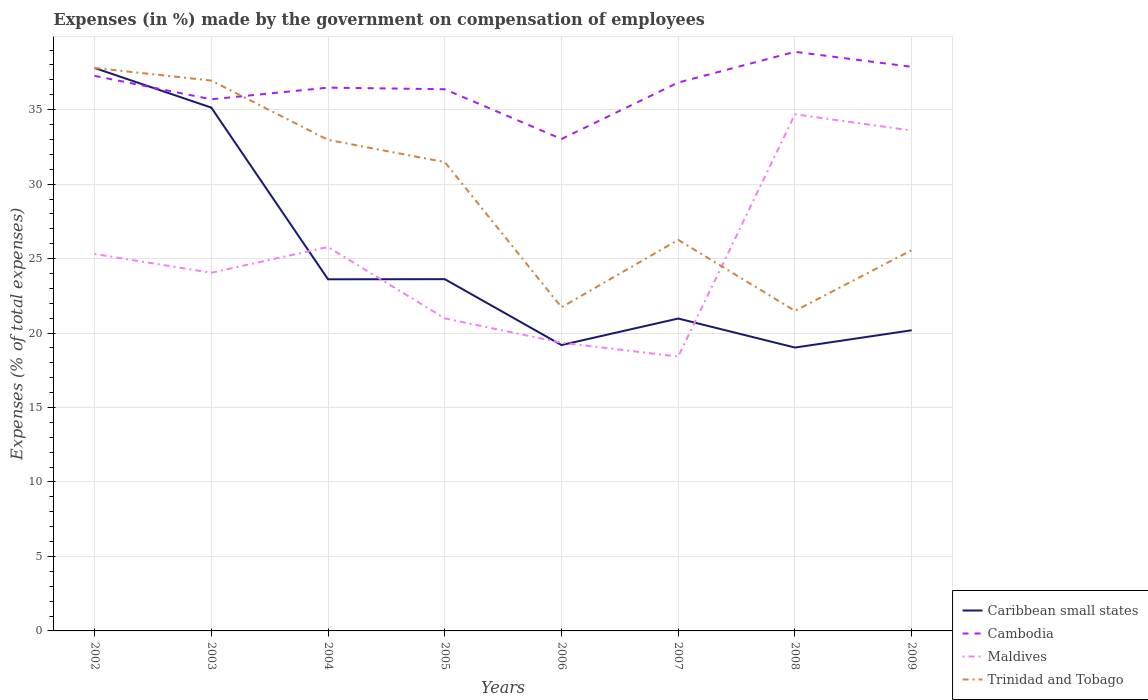Across all years, what is the maximum percentage of expenses made by the government on compensation of employees in Cambodia?
Give a very brief answer. 33.03. In which year was the percentage of expenses made by the government on compensation of employees in Cambodia maximum?
Provide a succinct answer. 2006. What is the total percentage of expenses made by the government on compensation of employees in Maldives in the graph?
Keep it short and to the point. -15.18. What is the difference between the highest and the second highest percentage of expenses made by the government on compensation of employees in Trinidad and Tobago?
Offer a very short reply. 16.31. What is the difference between two consecutive major ticks on the Y-axis?
Offer a terse response. 5. Are the values on the major ticks of Y-axis written in scientific E-notation?
Give a very brief answer. No. Does the graph contain any zero values?
Offer a very short reply. No. Where does the legend appear in the graph?
Provide a short and direct response. Bottom right. What is the title of the graph?
Provide a succinct answer. Expenses (in %) made by the government on compensation of employees. Does "Finland" appear as one of the legend labels in the graph?
Provide a succinct answer. No. What is the label or title of the Y-axis?
Your answer should be very brief. Expenses (% of total expenses). What is the Expenses (% of total expenses) of Caribbean small states in 2002?
Offer a terse response. 37.8. What is the Expenses (% of total expenses) of Cambodia in 2002?
Your answer should be very brief. 37.27. What is the Expenses (% of total expenses) of Maldives in 2002?
Offer a very short reply. 25.31. What is the Expenses (% of total expenses) in Trinidad and Tobago in 2002?
Offer a very short reply. 37.8. What is the Expenses (% of total expenses) of Caribbean small states in 2003?
Give a very brief answer. 35.14. What is the Expenses (% of total expenses) in Cambodia in 2003?
Your response must be concise. 35.7. What is the Expenses (% of total expenses) in Maldives in 2003?
Your answer should be compact. 24.05. What is the Expenses (% of total expenses) of Trinidad and Tobago in 2003?
Make the answer very short. 36.95. What is the Expenses (% of total expenses) of Caribbean small states in 2004?
Offer a very short reply. 23.61. What is the Expenses (% of total expenses) in Cambodia in 2004?
Offer a very short reply. 36.48. What is the Expenses (% of total expenses) in Maldives in 2004?
Give a very brief answer. 25.78. What is the Expenses (% of total expenses) in Trinidad and Tobago in 2004?
Provide a short and direct response. 32.97. What is the Expenses (% of total expenses) of Caribbean small states in 2005?
Offer a terse response. 23.62. What is the Expenses (% of total expenses) of Cambodia in 2005?
Make the answer very short. 36.37. What is the Expenses (% of total expenses) in Maldives in 2005?
Your answer should be very brief. 20.98. What is the Expenses (% of total expenses) in Trinidad and Tobago in 2005?
Your answer should be compact. 31.48. What is the Expenses (% of total expenses) of Caribbean small states in 2006?
Give a very brief answer. 19.19. What is the Expenses (% of total expenses) in Cambodia in 2006?
Make the answer very short. 33.03. What is the Expenses (% of total expenses) of Maldives in 2006?
Provide a succinct answer. 19.35. What is the Expenses (% of total expenses) of Trinidad and Tobago in 2006?
Keep it short and to the point. 21.73. What is the Expenses (% of total expenses) in Caribbean small states in 2007?
Offer a terse response. 20.98. What is the Expenses (% of total expenses) in Cambodia in 2007?
Provide a short and direct response. 36.82. What is the Expenses (% of total expenses) of Maldives in 2007?
Offer a very short reply. 18.42. What is the Expenses (% of total expenses) of Trinidad and Tobago in 2007?
Ensure brevity in your answer.  26.26. What is the Expenses (% of total expenses) of Caribbean small states in 2008?
Give a very brief answer. 19.03. What is the Expenses (% of total expenses) of Cambodia in 2008?
Your response must be concise. 38.88. What is the Expenses (% of total expenses) of Maldives in 2008?
Keep it short and to the point. 34.69. What is the Expenses (% of total expenses) in Trinidad and Tobago in 2008?
Provide a short and direct response. 21.49. What is the Expenses (% of total expenses) in Caribbean small states in 2009?
Make the answer very short. 20.19. What is the Expenses (% of total expenses) of Cambodia in 2009?
Ensure brevity in your answer.  37.88. What is the Expenses (% of total expenses) in Maldives in 2009?
Provide a succinct answer. 33.6. What is the Expenses (% of total expenses) in Trinidad and Tobago in 2009?
Give a very brief answer. 25.57. Across all years, what is the maximum Expenses (% of total expenses) of Caribbean small states?
Ensure brevity in your answer.  37.8. Across all years, what is the maximum Expenses (% of total expenses) in Cambodia?
Your response must be concise. 38.88. Across all years, what is the maximum Expenses (% of total expenses) in Maldives?
Your answer should be compact. 34.69. Across all years, what is the maximum Expenses (% of total expenses) in Trinidad and Tobago?
Make the answer very short. 37.8. Across all years, what is the minimum Expenses (% of total expenses) in Caribbean small states?
Make the answer very short. 19.03. Across all years, what is the minimum Expenses (% of total expenses) of Cambodia?
Provide a short and direct response. 33.03. Across all years, what is the minimum Expenses (% of total expenses) in Maldives?
Offer a very short reply. 18.42. Across all years, what is the minimum Expenses (% of total expenses) of Trinidad and Tobago?
Your response must be concise. 21.49. What is the total Expenses (% of total expenses) of Caribbean small states in the graph?
Provide a succinct answer. 199.54. What is the total Expenses (% of total expenses) in Cambodia in the graph?
Offer a very short reply. 292.42. What is the total Expenses (% of total expenses) of Maldives in the graph?
Your answer should be compact. 202.18. What is the total Expenses (% of total expenses) in Trinidad and Tobago in the graph?
Keep it short and to the point. 234.25. What is the difference between the Expenses (% of total expenses) of Caribbean small states in 2002 and that in 2003?
Provide a short and direct response. 2.66. What is the difference between the Expenses (% of total expenses) of Cambodia in 2002 and that in 2003?
Your response must be concise. 1.57. What is the difference between the Expenses (% of total expenses) in Maldives in 2002 and that in 2003?
Offer a very short reply. 1.26. What is the difference between the Expenses (% of total expenses) of Trinidad and Tobago in 2002 and that in 2003?
Offer a very short reply. 0.84. What is the difference between the Expenses (% of total expenses) of Caribbean small states in 2002 and that in 2004?
Your answer should be very brief. 14.19. What is the difference between the Expenses (% of total expenses) in Cambodia in 2002 and that in 2004?
Make the answer very short. 0.79. What is the difference between the Expenses (% of total expenses) of Maldives in 2002 and that in 2004?
Make the answer very short. -0.47. What is the difference between the Expenses (% of total expenses) in Trinidad and Tobago in 2002 and that in 2004?
Offer a terse response. 4.83. What is the difference between the Expenses (% of total expenses) of Caribbean small states in 2002 and that in 2005?
Offer a very short reply. 14.18. What is the difference between the Expenses (% of total expenses) in Cambodia in 2002 and that in 2005?
Provide a succinct answer. 0.9. What is the difference between the Expenses (% of total expenses) of Maldives in 2002 and that in 2005?
Offer a terse response. 4.33. What is the difference between the Expenses (% of total expenses) in Trinidad and Tobago in 2002 and that in 2005?
Give a very brief answer. 6.32. What is the difference between the Expenses (% of total expenses) of Caribbean small states in 2002 and that in 2006?
Your response must be concise. 18.6. What is the difference between the Expenses (% of total expenses) of Cambodia in 2002 and that in 2006?
Offer a very short reply. 4.24. What is the difference between the Expenses (% of total expenses) in Maldives in 2002 and that in 2006?
Give a very brief answer. 5.96. What is the difference between the Expenses (% of total expenses) in Trinidad and Tobago in 2002 and that in 2006?
Provide a succinct answer. 16.07. What is the difference between the Expenses (% of total expenses) in Caribbean small states in 2002 and that in 2007?
Your answer should be compact. 16.82. What is the difference between the Expenses (% of total expenses) in Cambodia in 2002 and that in 2007?
Ensure brevity in your answer.  0.45. What is the difference between the Expenses (% of total expenses) of Maldives in 2002 and that in 2007?
Your response must be concise. 6.89. What is the difference between the Expenses (% of total expenses) in Trinidad and Tobago in 2002 and that in 2007?
Your response must be concise. 11.54. What is the difference between the Expenses (% of total expenses) of Caribbean small states in 2002 and that in 2008?
Your answer should be compact. 18.77. What is the difference between the Expenses (% of total expenses) in Cambodia in 2002 and that in 2008?
Ensure brevity in your answer.  -1.61. What is the difference between the Expenses (% of total expenses) in Maldives in 2002 and that in 2008?
Ensure brevity in your answer.  -9.38. What is the difference between the Expenses (% of total expenses) in Trinidad and Tobago in 2002 and that in 2008?
Offer a terse response. 16.31. What is the difference between the Expenses (% of total expenses) of Caribbean small states in 2002 and that in 2009?
Provide a short and direct response. 17.61. What is the difference between the Expenses (% of total expenses) of Cambodia in 2002 and that in 2009?
Ensure brevity in your answer.  -0.61. What is the difference between the Expenses (% of total expenses) in Maldives in 2002 and that in 2009?
Provide a succinct answer. -8.29. What is the difference between the Expenses (% of total expenses) of Trinidad and Tobago in 2002 and that in 2009?
Keep it short and to the point. 12.23. What is the difference between the Expenses (% of total expenses) in Caribbean small states in 2003 and that in 2004?
Provide a short and direct response. 11.53. What is the difference between the Expenses (% of total expenses) of Cambodia in 2003 and that in 2004?
Provide a succinct answer. -0.78. What is the difference between the Expenses (% of total expenses) of Maldives in 2003 and that in 2004?
Make the answer very short. -1.73. What is the difference between the Expenses (% of total expenses) in Trinidad and Tobago in 2003 and that in 2004?
Provide a short and direct response. 3.98. What is the difference between the Expenses (% of total expenses) of Caribbean small states in 2003 and that in 2005?
Offer a very short reply. 11.52. What is the difference between the Expenses (% of total expenses) in Cambodia in 2003 and that in 2005?
Offer a very short reply. -0.68. What is the difference between the Expenses (% of total expenses) of Maldives in 2003 and that in 2005?
Ensure brevity in your answer.  3.07. What is the difference between the Expenses (% of total expenses) in Trinidad and Tobago in 2003 and that in 2005?
Make the answer very short. 5.48. What is the difference between the Expenses (% of total expenses) in Caribbean small states in 2003 and that in 2006?
Give a very brief answer. 15.94. What is the difference between the Expenses (% of total expenses) in Cambodia in 2003 and that in 2006?
Provide a short and direct response. 2.67. What is the difference between the Expenses (% of total expenses) of Maldives in 2003 and that in 2006?
Offer a very short reply. 4.7. What is the difference between the Expenses (% of total expenses) of Trinidad and Tobago in 2003 and that in 2006?
Provide a succinct answer. 15.22. What is the difference between the Expenses (% of total expenses) in Caribbean small states in 2003 and that in 2007?
Keep it short and to the point. 14.16. What is the difference between the Expenses (% of total expenses) in Cambodia in 2003 and that in 2007?
Your answer should be very brief. -1.13. What is the difference between the Expenses (% of total expenses) of Maldives in 2003 and that in 2007?
Your response must be concise. 5.63. What is the difference between the Expenses (% of total expenses) of Trinidad and Tobago in 2003 and that in 2007?
Ensure brevity in your answer.  10.7. What is the difference between the Expenses (% of total expenses) of Caribbean small states in 2003 and that in 2008?
Provide a succinct answer. 16.11. What is the difference between the Expenses (% of total expenses) in Cambodia in 2003 and that in 2008?
Provide a short and direct response. -3.19. What is the difference between the Expenses (% of total expenses) in Maldives in 2003 and that in 2008?
Offer a terse response. -10.64. What is the difference between the Expenses (% of total expenses) of Trinidad and Tobago in 2003 and that in 2008?
Offer a very short reply. 15.46. What is the difference between the Expenses (% of total expenses) in Caribbean small states in 2003 and that in 2009?
Your answer should be compact. 14.95. What is the difference between the Expenses (% of total expenses) in Cambodia in 2003 and that in 2009?
Make the answer very short. -2.18. What is the difference between the Expenses (% of total expenses) in Maldives in 2003 and that in 2009?
Keep it short and to the point. -9.55. What is the difference between the Expenses (% of total expenses) in Trinidad and Tobago in 2003 and that in 2009?
Your response must be concise. 11.39. What is the difference between the Expenses (% of total expenses) in Caribbean small states in 2004 and that in 2005?
Provide a succinct answer. -0.01. What is the difference between the Expenses (% of total expenses) in Cambodia in 2004 and that in 2005?
Your answer should be very brief. 0.11. What is the difference between the Expenses (% of total expenses) of Maldives in 2004 and that in 2005?
Offer a very short reply. 4.79. What is the difference between the Expenses (% of total expenses) in Trinidad and Tobago in 2004 and that in 2005?
Your response must be concise. 1.49. What is the difference between the Expenses (% of total expenses) of Caribbean small states in 2004 and that in 2006?
Keep it short and to the point. 4.41. What is the difference between the Expenses (% of total expenses) in Cambodia in 2004 and that in 2006?
Give a very brief answer. 3.45. What is the difference between the Expenses (% of total expenses) in Maldives in 2004 and that in 2006?
Ensure brevity in your answer.  6.43. What is the difference between the Expenses (% of total expenses) in Trinidad and Tobago in 2004 and that in 2006?
Provide a short and direct response. 11.24. What is the difference between the Expenses (% of total expenses) of Caribbean small states in 2004 and that in 2007?
Provide a succinct answer. 2.63. What is the difference between the Expenses (% of total expenses) of Cambodia in 2004 and that in 2007?
Keep it short and to the point. -0.34. What is the difference between the Expenses (% of total expenses) in Maldives in 2004 and that in 2007?
Give a very brief answer. 7.36. What is the difference between the Expenses (% of total expenses) in Trinidad and Tobago in 2004 and that in 2007?
Provide a succinct answer. 6.71. What is the difference between the Expenses (% of total expenses) in Caribbean small states in 2004 and that in 2008?
Offer a terse response. 4.58. What is the difference between the Expenses (% of total expenses) of Cambodia in 2004 and that in 2008?
Ensure brevity in your answer.  -2.41. What is the difference between the Expenses (% of total expenses) of Maldives in 2004 and that in 2008?
Offer a terse response. -8.91. What is the difference between the Expenses (% of total expenses) of Trinidad and Tobago in 2004 and that in 2008?
Make the answer very short. 11.48. What is the difference between the Expenses (% of total expenses) in Caribbean small states in 2004 and that in 2009?
Make the answer very short. 3.42. What is the difference between the Expenses (% of total expenses) in Cambodia in 2004 and that in 2009?
Your answer should be very brief. -1.4. What is the difference between the Expenses (% of total expenses) in Maldives in 2004 and that in 2009?
Offer a very short reply. -7.82. What is the difference between the Expenses (% of total expenses) in Trinidad and Tobago in 2004 and that in 2009?
Offer a very short reply. 7.4. What is the difference between the Expenses (% of total expenses) in Caribbean small states in 2005 and that in 2006?
Your response must be concise. 4.42. What is the difference between the Expenses (% of total expenses) of Cambodia in 2005 and that in 2006?
Your response must be concise. 3.34. What is the difference between the Expenses (% of total expenses) in Maldives in 2005 and that in 2006?
Your response must be concise. 1.63. What is the difference between the Expenses (% of total expenses) in Trinidad and Tobago in 2005 and that in 2006?
Offer a very short reply. 9.75. What is the difference between the Expenses (% of total expenses) of Caribbean small states in 2005 and that in 2007?
Your response must be concise. 2.64. What is the difference between the Expenses (% of total expenses) of Cambodia in 2005 and that in 2007?
Your answer should be very brief. -0.45. What is the difference between the Expenses (% of total expenses) of Maldives in 2005 and that in 2007?
Provide a short and direct response. 2.56. What is the difference between the Expenses (% of total expenses) of Trinidad and Tobago in 2005 and that in 2007?
Provide a short and direct response. 5.22. What is the difference between the Expenses (% of total expenses) in Caribbean small states in 2005 and that in 2008?
Offer a very short reply. 4.59. What is the difference between the Expenses (% of total expenses) of Cambodia in 2005 and that in 2008?
Your response must be concise. -2.51. What is the difference between the Expenses (% of total expenses) of Maldives in 2005 and that in 2008?
Your answer should be compact. -13.71. What is the difference between the Expenses (% of total expenses) of Trinidad and Tobago in 2005 and that in 2008?
Give a very brief answer. 9.99. What is the difference between the Expenses (% of total expenses) of Caribbean small states in 2005 and that in 2009?
Your answer should be compact. 3.43. What is the difference between the Expenses (% of total expenses) of Cambodia in 2005 and that in 2009?
Your answer should be compact. -1.5. What is the difference between the Expenses (% of total expenses) of Maldives in 2005 and that in 2009?
Keep it short and to the point. -12.61. What is the difference between the Expenses (% of total expenses) in Trinidad and Tobago in 2005 and that in 2009?
Offer a very short reply. 5.91. What is the difference between the Expenses (% of total expenses) in Caribbean small states in 2006 and that in 2007?
Offer a very short reply. -1.78. What is the difference between the Expenses (% of total expenses) of Cambodia in 2006 and that in 2007?
Your answer should be very brief. -3.79. What is the difference between the Expenses (% of total expenses) of Maldives in 2006 and that in 2007?
Provide a succinct answer. 0.93. What is the difference between the Expenses (% of total expenses) in Trinidad and Tobago in 2006 and that in 2007?
Give a very brief answer. -4.53. What is the difference between the Expenses (% of total expenses) of Caribbean small states in 2006 and that in 2008?
Your answer should be very brief. 0.17. What is the difference between the Expenses (% of total expenses) in Cambodia in 2006 and that in 2008?
Give a very brief answer. -5.85. What is the difference between the Expenses (% of total expenses) of Maldives in 2006 and that in 2008?
Your response must be concise. -15.34. What is the difference between the Expenses (% of total expenses) in Trinidad and Tobago in 2006 and that in 2008?
Give a very brief answer. 0.24. What is the difference between the Expenses (% of total expenses) of Caribbean small states in 2006 and that in 2009?
Provide a short and direct response. -0.99. What is the difference between the Expenses (% of total expenses) of Cambodia in 2006 and that in 2009?
Offer a terse response. -4.85. What is the difference between the Expenses (% of total expenses) in Maldives in 2006 and that in 2009?
Give a very brief answer. -14.25. What is the difference between the Expenses (% of total expenses) of Trinidad and Tobago in 2006 and that in 2009?
Your response must be concise. -3.84. What is the difference between the Expenses (% of total expenses) in Caribbean small states in 2007 and that in 2008?
Offer a very short reply. 1.95. What is the difference between the Expenses (% of total expenses) of Cambodia in 2007 and that in 2008?
Offer a very short reply. -2.06. What is the difference between the Expenses (% of total expenses) in Maldives in 2007 and that in 2008?
Offer a very short reply. -16.27. What is the difference between the Expenses (% of total expenses) in Trinidad and Tobago in 2007 and that in 2008?
Keep it short and to the point. 4.77. What is the difference between the Expenses (% of total expenses) of Caribbean small states in 2007 and that in 2009?
Ensure brevity in your answer.  0.79. What is the difference between the Expenses (% of total expenses) in Cambodia in 2007 and that in 2009?
Offer a very short reply. -1.05. What is the difference between the Expenses (% of total expenses) in Maldives in 2007 and that in 2009?
Give a very brief answer. -15.18. What is the difference between the Expenses (% of total expenses) in Trinidad and Tobago in 2007 and that in 2009?
Make the answer very short. 0.69. What is the difference between the Expenses (% of total expenses) in Caribbean small states in 2008 and that in 2009?
Ensure brevity in your answer.  -1.16. What is the difference between the Expenses (% of total expenses) in Cambodia in 2008 and that in 2009?
Give a very brief answer. 1.01. What is the difference between the Expenses (% of total expenses) in Maldives in 2008 and that in 2009?
Give a very brief answer. 1.09. What is the difference between the Expenses (% of total expenses) in Trinidad and Tobago in 2008 and that in 2009?
Give a very brief answer. -4.08. What is the difference between the Expenses (% of total expenses) in Caribbean small states in 2002 and the Expenses (% of total expenses) in Cambodia in 2003?
Provide a succinct answer. 2.1. What is the difference between the Expenses (% of total expenses) of Caribbean small states in 2002 and the Expenses (% of total expenses) of Maldives in 2003?
Make the answer very short. 13.75. What is the difference between the Expenses (% of total expenses) of Caribbean small states in 2002 and the Expenses (% of total expenses) of Trinidad and Tobago in 2003?
Keep it short and to the point. 0.84. What is the difference between the Expenses (% of total expenses) in Cambodia in 2002 and the Expenses (% of total expenses) in Maldives in 2003?
Give a very brief answer. 13.22. What is the difference between the Expenses (% of total expenses) in Cambodia in 2002 and the Expenses (% of total expenses) in Trinidad and Tobago in 2003?
Your answer should be very brief. 0.32. What is the difference between the Expenses (% of total expenses) in Maldives in 2002 and the Expenses (% of total expenses) in Trinidad and Tobago in 2003?
Offer a terse response. -11.64. What is the difference between the Expenses (% of total expenses) of Caribbean small states in 2002 and the Expenses (% of total expenses) of Cambodia in 2004?
Make the answer very short. 1.32. What is the difference between the Expenses (% of total expenses) of Caribbean small states in 2002 and the Expenses (% of total expenses) of Maldives in 2004?
Provide a succinct answer. 12.02. What is the difference between the Expenses (% of total expenses) of Caribbean small states in 2002 and the Expenses (% of total expenses) of Trinidad and Tobago in 2004?
Provide a succinct answer. 4.83. What is the difference between the Expenses (% of total expenses) of Cambodia in 2002 and the Expenses (% of total expenses) of Maldives in 2004?
Provide a succinct answer. 11.49. What is the difference between the Expenses (% of total expenses) of Cambodia in 2002 and the Expenses (% of total expenses) of Trinidad and Tobago in 2004?
Provide a succinct answer. 4.3. What is the difference between the Expenses (% of total expenses) in Maldives in 2002 and the Expenses (% of total expenses) in Trinidad and Tobago in 2004?
Provide a succinct answer. -7.66. What is the difference between the Expenses (% of total expenses) in Caribbean small states in 2002 and the Expenses (% of total expenses) in Cambodia in 2005?
Your response must be concise. 1.43. What is the difference between the Expenses (% of total expenses) in Caribbean small states in 2002 and the Expenses (% of total expenses) in Maldives in 2005?
Provide a short and direct response. 16.81. What is the difference between the Expenses (% of total expenses) in Caribbean small states in 2002 and the Expenses (% of total expenses) in Trinidad and Tobago in 2005?
Your answer should be compact. 6.32. What is the difference between the Expenses (% of total expenses) of Cambodia in 2002 and the Expenses (% of total expenses) of Maldives in 2005?
Make the answer very short. 16.29. What is the difference between the Expenses (% of total expenses) of Cambodia in 2002 and the Expenses (% of total expenses) of Trinidad and Tobago in 2005?
Your response must be concise. 5.79. What is the difference between the Expenses (% of total expenses) of Maldives in 2002 and the Expenses (% of total expenses) of Trinidad and Tobago in 2005?
Your response must be concise. -6.17. What is the difference between the Expenses (% of total expenses) in Caribbean small states in 2002 and the Expenses (% of total expenses) in Cambodia in 2006?
Provide a short and direct response. 4.77. What is the difference between the Expenses (% of total expenses) in Caribbean small states in 2002 and the Expenses (% of total expenses) in Maldives in 2006?
Your answer should be very brief. 18.45. What is the difference between the Expenses (% of total expenses) of Caribbean small states in 2002 and the Expenses (% of total expenses) of Trinidad and Tobago in 2006?
Keep it short and to the point. 16.07. What is the difference between the Expenses (% of total expenses) of Cambodia in 2002 and the Expenses (% of total expenses) of Maldives in 2006?
Your answer should be very brief. 17.92. What is the difference between the Expenses (% of total expenses) in Cambodia in 2002 and the Expenses (% of total expenses) in Trinidad and Tobago in 2006?
Provide a succinct answer. 15.54. What is the difference between the Expenses (% of total expenses) in Maldives in 2002 and the Expenses (% of total expenses) in Trinidad and Tobago in 2006?
Offer a terse response. 3.58. What is the difference between the Expenses (% of total expenses) of Caribbean small states in 2002 and the Expenses (% of total expenses) of Cambodia in 2007?
Your answer should be very brief. 0.98. What is the difference between the Expenses (% of total expenses) in Caribbean small states in 2002 and the Expenses (% of total expenses) in Maldives in 2007?
Keep it short and to the point. 19.38. What is the difference between the Expenses (% of total expenses) of Caribbean small states in 2002 and the Expenses (% of total expenses) of Trinidad and Tobago in 2007?
Give a very brief answer. 11.54. What is the difference between the Expenses (% of total expenses) in Cambodia in 2002 and the Expenses (% of total expenses) in Maldives in 2007?
Offer a very short reply. 18.85. What is the difference between the Expenses (% of total expenses) in Cambodia in 2002 and the Expenses (% of total expenses) in Trinidad and Tobago in 2007?
Provide a short and direct response. 11.01. What is the difference between the Expenses (% of total expenses) in Maldives in 2002 and the Expenses (% of total expenses) in Trinidad and Tobago in 2007?
Your answer should be very brief. -0.95. What is the difference between the Expenses (% of total expenses) of Caribbean small states in 2002 and the Expenses (% of total expenses) of Cambodia in 2008?
Keep it short and to the point. -1.09. What is the difference between the Expenses (% of total expenses) in Caribbean small states in 2002 and the Expenses (% of total expenses) in Maldives in 2008?
Your response must be concise. 3.11. What is the difference between the Expenses (% of total expenses) of Caribbean small states in 2002 and the Expenses (% of total expenses) of Trinidad and Tobago in 2008?
Your answer should be compact. 16.31. What is the difference between the Expenses (% of total expenses) of Cambodia in 2002 and the Expenses (% of total expenses) of Maldives in 2008?
Your response must be concise. 2.58. What is the difference between the Expenses (% of total expenses) in Cambodia in 2002 and the Expenses (% of total expenses) in Trinidad and Tobago in 2008?
Your response must be concise. 15.78. What is the difference between the Expenses (% of total expenses) in Maldives in 2002 and the Expenses (% of total expenses) in Trinidad and Tobago in 2008?
Your response must be concise. 3.82. What is the difference between the Expenses (% of total expenses) in Caribbean small states in 2002 and the Expenses (% of total expenses) in Cambodia in 2009?
Your response must be concise. -0.08. What is the difference between the Expenses (% of total expenses) in Caribbean small states in 2002 and the Expenses (% of total expenses) in Maldives in 2009?
Make the answer very short. 4.2. What is the difference between the Expenses (% of total expenses) of Caribbean small states in 2002 and the Expenses (% of total expenses) of Trinidad and Tobago in 2009?
Keep it short and to the point. 12.23. What is the difference between the Expenses (% of total expenses) in Cambodia in 2002 and the Expenses (% of total expenses) in Maldives in 2009?
Your response must be concise. 3.67. What is the difference between the Expenses (% of total expenses) in Cambodia in 2002 and the Expenses (% of total expenses) in Trinidad and Tobago in 2009?
Ensure brevity in your answer.  11.7. What is the difference between the Expenses (% of total expenses) in Maldives in 2002 and the Expenses (% of total expenses) in Trinidad and Tobago in 2009?
Make the answer very short. -0.26. What is the difference between the Expenses (% of total expenses) in Caribbean small states in 2003 and the Expenses (% of total expenses) in Cambodia in 2004?
Your response must be concise. -1.34. What is the difference between the Expenses (% of total expenses) in Caribbean small states in 2003 and the Expenses (% of total expenses) in Maldives in 2004?
Offer a terse response. 9.36. What is the difference between the Expenses (% of total expenses) in Caribbean small states in 2003 and the Expenses (% of total expenses) in Trinidad and Tobago in 2004?
Make the answer very short. 2.17. What is the difference between the Expenses (% of total expenses) in Cambodia in 2003 and the Expenses (% of total expenses) in Maldives in 2004?
Keep it short and to the point. 9.92. What is the difference between the Expenses (% of total expenses) of Cambodia in 2003 and the Expenses (% of total expenses) of Trinidad and Tobago in 2004?
Your answer should be very brief. 2.72. What is the difference between the Expenses (% of total expenses) in Maldives in 2003 and the Expenses (% of total expenses) in Trinidad and Tobago in 2004?
Your answer should be very brief. -8.92. What is the difference between the Expenses (% of total expenses) in Caribbean small states in 2003 and the Expenses (% of total expenses) in Cambodia in 2005?
Offer a very short reply. -1.23. What is the difference between the Expenses (% of total expenses) of Caribbean small states in 2003 and the Expenses (% of total expenses) of Maldives in 2005?
Offer a very short reply. 14.15. What is the difference between the Expenses (% of total expenses) of Caribbean small states in 2003 and the Expenses (% of total expenses) of Trinidad and Tobago in 2005?
Your answer should be compact. 3.66. What is the difference between the Expenses (% of total expenses) in Cambodia in 2003 and the Expenses (% of total expenses) in Maldives in 2005?
Provide a short and direct response. 14.71. What is the difference between the Expenses (% of total expenses) of Cambodia in 2003 and the Expenses (% of total expenses) of Trinidad and Tobago in 2005?
Make the answer very short. 4.22. What is the difference between the Expenses (% of total expenses) of Maldives in 2003 and the Expenses (% of total expenses) of Trinidad and Tobago in 2005?
Ensure brevity in your answer.  -7.43. What is the difference between the Expenses (% of total expenses) in Caribbean small states in 2003 and the Expenses (% of total expenses) in Cambodia in 2006?
Ensure brevity in your answer.  2.11. What is the difference between the Expenses (% of total expenses) in Caribbean small states in 2003 and the Expenses (% of total expenses) in Maldives in 2006?
Provide a short and direct response. 15.79. What is the difference between the Expenses (% of total expenses) of Caribbean small states in 2003 and the Expenses (% of total expenses) of Trinidad and Tobago in 2006?
Your response must be concise. 13.41. What is the difference between the Expenses (% of total expenses) in Cambodia in 2003 and the Expenses (% of total expenses) in Maldives in 2006?
Keep it short and to the point. 16.35. What is the difference between the Expenses (% of total expenses) in Cambodia in 2003 and the Expenses (% of total expenses) in Trinidad and Tobago in 2006?
Your response must be concise. 13.96. What is the difference between the Expenses (% of total expenses) of Maldives in 2003 and the Expenses (% of total expenses) of Trinidad and Tobago in 2006?
Ensure brevity in your answer.  2.32. What is the difference between the Expenses (% of total expenses) of Caribbean small states in 2003 and the Expenses (% of total expenses) of Cambodia in 2007?
Keep it short and to the point. -1.68. What is the difference between the Expenses (% of total expenses) of Caribbean small states in 2003 and the Expenses (% of total expenses) of Maldives in 2007?
Give a very brief answer. 16.72. What is the difference between the Expenses (% of total expenses) of Caribbean small states in 2003 and the Expenses (% of total expenses) of Trinidad and Tobago in 2007?
Provide a short and direct response. 8.88. What is the difference between the Expenses (% of total expenses) in Cambodia in 2003 and the Expenses (% of total expenses) in Maldives in 2007?
Ensure brevity in your answer.  17.27. What is the difference between the Expenses (% of total expenses) of Cambodia in 2003 and the Expenses (% of total expenses) of Trinidad and Tobago in 2007?
Provide a short and direct response. 9.44. What is the difference between the Expenses (% of total expenses) in Maldives in 2003 and the Expenses (% of total expenses) in Trinidad and Tobago in 2007?
Your response must be concise. -2.21. What is the difference between the Expenses (% of total expenses) of Caribbean small states in 2003 and the Expenses (% of total expenses) of Cambodia in 2008?
Your response must be concise. -3.75. What is the difference between the Expenses (% of total expenses) of Caribbean small states in 2003 and the Expenses (% of total expenses) of Maldives in 2008?
Your answer should be very brief. 0.45. What is the difference between the Expenses (% of total expenses) of Caribbean small states in 2003 and the Expenses (% of total expenses) of Trinidad and Tobago in 2008?
Provide a short and direct response. 13.65. What is the difference between the Expenses (% of total expenses) of Cambodia in 2003 and the Expenses (% of total expenses) of Trinidad and Tobago in 2008?
Keep it short and to the point. 14.21. What is the difference between the Expenses (% of total expenses) of Maldives in 2003 and the Expenses (% of total expenses) of Trinidad and Tobago in 2008?
Provide a succinct answer. 2.56. What is the difference between the Expenses (% of total expenses) in Caribbean small states in 2003 and the Expenses (% of total expenses) in Cambodia in 2009?
Make the answer very short. -2.74. What is the difference between the Expenses (% of total expenses) in Caribbean small states in 2003 and the Expenses (% of total expenses) in Maldives in 2009?
Your answer should be compact. 1.54. What is the difference between the Expenses (% of total expenses) in Caribbean small states in 2003 and the Expenses (% of total expenses) in Trinidad and Tobago in 2009?
Offer a terse response. 9.57. What is the difference between the Expenses (% of total expenses) of Cambodia in 2003 and the Expenses (% of total expenses) of Maldives in 2009?
Give a very brief answer. 2.1. What is the difference between the Expenses (% of total expenses) of Cambodia in 2003 and the Expenses (% of total expenses) of Trinidad and Tobago in 2009?
Your response must be concise. 10.13. What is the difference between the Expenses (% of total expenses) of Maldives in 2003 and the Expenses (% of total expenses) of Trinidad and Tobago in 2009?
Keep it short and to the point. -1.52. What is the difference between the Expenses (% of total expenses) of Caribbean small states in 2004 and the Expenses (% of total expenses) of Cambodia in 2005?
Make the answer very short. -12.76. What is the difference between the Expenses (% of total expenses) of Caribbean small states in 2004 and the Expenses (% of total expenses) of Maldives in 2005?
Provide a succinct answer. 2.63. What is the difference between the Expenses (% of total expenses) of Caribbean small states in 2004 and the Expenses (% of total expenses) of Trinidad and Tobago in 2005?
Provide a succinct answer. -7.87. What is the difference between the Expenses (% of total expenses) of Cambodia in 2004 and the Expenses (% of total expenses) of Maldives in 2005?
Provide a short and direct response. 15.5. What is the difference between the Expenses (% of total expenses) in Cambodia in 2004 and the Expenses (% of total expenses) in Trinidad and Tobago in 2005?
Your answer should be very brief. 5. What is the difference between the Expenses (% of total expenses) of Maldives in 2004 and the Expenses (% of total expenses) of Trinidad and Tobago in 2005?
Make the answer very short. -5.7. What is the difference between the Expenses (% of total expenses) in Caribbean small states in 2004 and the Expenses (% of total expenses) in Cambodia in 2006?
Provide a succinct answer. -9.42. What is the difference between the Expenses (% of total expenses) in Caribbean small states in 2004 and the Expenses (% of total expenses) in Maldives in 2006?
Ensure brevity in your answer.  4.26. What is the difference between the Expenses (% of total expenses) in Caribbean small states in 2004 and the Expenses (% of total expenses) in Trinidad and Tobago in 2006?
Offer a terse response. 1.88. What is the difference between the Expenses (% of total expenses) in Cambodia in 2004 and the Expenses (% of total expenses) in Maldives in 2006?
Provide a short and direct response. 17.13. What is the difference between the Expenses (% of total expenses) in Cambodia in 2004 and the Expenses (% of total expenses) in Trinidad and Tobago in 2006?
Keep it short and to the point. 14.75. What is the difference between the Expenses (% of total expenses) in Maldives in 2004 and the Expenses (% of total expenses) in Trinidad and Tobago in 2006?
Keep it short and to the point. 4.05. What is the difference between the Expenses (% of total expenses) of Caribbean small states in 2004 and the Expenses (% of total expenses) of Cambodia in 2007?
Your answer should be very brief. -13.21. What is the difference between the Expenses (% of total expenses) of Caribbean small states in 2004 and the Expenses (% of total expenses) of Maldives in 2007?
Provide a short and direct response. 5.19. What is the difference between the Expenses (% of total expenses) of Caribbean small states in 2004 and the Expenses (% of total expenses) of Trinidad and Tobago in 2007?
Make the answer very short. -2.65. What is the difference between the Expenses (% of total expenses) in Cambodia in 2004 and the Expenses (% of total expenses) in Maldives in 2007?
Give a very brief answer. 18.06. What is the difference between the Expenses (% of total expenses) of Cambodia in 2004 and the Expenses (% of total expenses) of Trinidad and Tobago in 2007?
Offer a terse response. 10.22. What is the difference between the Expenses (% of total expenses) in Maldives in 2004 and the Expenses (% of total expenses) in Trinidad and Tobago in 2007?
Give a very brief answer. -0.48. What is the difference between the Expenses (% of total expenses) of Caribbean small states in 2004 and the Expenses (% of total expenses) of Cambodia in 2008?
Keep it short and to the point. -15.27. What is the difference between the Expenses (% of total expenses) of Caribbean small states in 2004 and the Expenses (% of total expenses) of Maldives in 2008?
Make the answer very short. -11.08. What is the difference between the Expenses (% of total expenses) of Caribbean small states in 2004 and the Expenses (% of total expenses) of Trinidad and Tobago in 2008?
Keep it short and to the point. 2.12. What is the difference between the Expenses (% of total expenses) in Cambodia in 2004 and the Expenses (% of total expenses) in Maldives in 2008?
Make the answer very short. 1.79. What is the difference between the Expenses (% of total expenses) in Cambodia in 2004 and the Expenses (% of total expenses) in Trinidad and Tobago in 2008?
Your response must be concise. 14.99. What is the difference between the Expenses (% of total expenses) of Maldives in 2004 and the Expenses (% of total expenses) of Trinidad and Tobago in 2008?
Provide a succinct answer. 4.29. What is the difference between the Expenses (% of total expenses) of Caribbean small states in 2004 and the Expenses (% of total expenses) of Cambodia in 2009?
Make the answer very short. -14.27. What is the difference between the Expenses (% of total expenses) in Caribbean small states in 2004 and the Expenses (% of total expenses) in Maldives in 2009?
Give a very brief answer. -9.99. What is the difference between the Expenses (% of total expenses) in Caribbean small states in 2004 and the Expenses (% of total expenses) in Trinidad and Tobago in 2009?
Ensure brevity in your answer.  -1.96. What is the difference between the Expenses (% of total expenses) in Cambodia in 2004 and the Expenses (% of total expenses) in Maldives in 2009?
Keep it short and to the point. 2.88. What is the difference between the Expenses (% of total expenses) in Cambodia in 2004 and the Expenses (% of total expenses) in Trinidad and Tobago in 2009?
Ensure brevity in your answer.  10.91. What is the difference between the Expenses (% of total expenses) of Maldives in 2004 and the Expenses (% of total expenses) of Trinidad and Tobago in 2009?
Offer a terse response. 0.21. What is the difference between the Expenses (% of total expenses) in Caribbean small states in 2005 and the Expenses (% of total expenses) in Cambodia in 2006?
Provide a short and direct response. -9.41. What is the difference between the Expenses (% of total expenses) in Caribbean small states in 2005 and the Expenses (% of total expenses) in Maldives in 2006?
Make the answer very short. 4.27. What is the difference between the Expenses (% of total expenses) of Caribbean small states in 2005 and the Expenses (% of total expenses) of Trinidad and Tobago in 2006?
Provide a short and direct response. 1.89. What is the difference between the Expenses (% of total expenses) in Cambodia in 2005 and the Expenses (% of total expenses) in Maldives in 2006?
Offer a very short reply. 17.02. What is the difference between the Expenses (% of total expenses) of Cambodia in 2005 and the Expenses (% of total expenses) of Trinidad and Tobago in 2006?
Your answer should be compact. 14.64. What is the difference between the Expenses (% of total expenses) in Maldives in 2005 and the Expenses (% of total expenses) in Trinidad and Tobago in 2006?
Offer a very short reply. -0.75. What is the difference between the Expenses (% of total expenses) in Caribbean small states in 2005 and the Expenses (% of total expenses) in Cambodia in 2007?
Offer a very short reply. -13.2. What is the difference between the Expenses (% of total expenses) of Caribbean small states in 2005 and the Expenses (% of total expenses) of Maldives in 2007?
Provide a short and direct response. 5.2. What is the difference between the Expenses (% of total expenses) of Caribbean small states in 2005 and the Expenses (% of total expenses) of Trinidad and Tobago in 2007?
Offer a very short reply. -2.64. What is the difference between the Expenses (% of total expenses) in Cambodia in 2005 and the Expenses (% of total expenses) in Maldives in 2007?
Your answer should be very brief. 17.95. What is the difference between the Expenses (% of total expenses) of Cambodia in 2005 and the Expenses (% of total expenses) of Trinidad and Tobago in 2007?
Make the answer very short. 10.11. What is the difference between the Expenses (% of total expenses) of Maldives in 2005 and the Expenses (% of total expenses) of Trinidad and Tobago in 2007?
Keep it short and to the point. -5.27. What is the difference between the Expenses (% of total expenses) in Caribbean small states in 2005 and the Expenses (% of total expenses) in Cambodia in 2008?
Offer a terse response. -15.27. What is the difference between the Expenses (% of total expenses) of Caribbean small states in 2005 and the Expenses (% of total expenses) of Maldives in 2008?
Your answer should be very brief. -11.07. What is the difference between the Expenses (% of total expenses) of Caribbean small states in 2005 and the Expenses (% of total expenses) of Trinidad and Tobago in 2008?
Provide a succinct answer. 2.13. What is the difference between the Expenses (% of total expenses) in Cambodia in 2005 and the Expenses (% of total expenses) in Maldives in 2008?
Ensure brevity in your answer.  1.68. What is the difference between the Expenses (% of total expenses) of Cambodia in 2005 and the Expenses (% of total expenses) of Trinidad and Tobago in 2008?
Offer a very short reply. 14.88. What is the difference between the Expenses (% of total expenses) in Maldives in 2005 and the Expenses (% of total expenses) in Trinidad and Tobago in 2008?
Keep it short and to the point. -0.51. What is the difference between the Expenses (% of total expenses) of Caribbean small states in 2005 and the Expenses (% of total expenses) of Cambodia in 2009?
Provide a succinct answer. -14.26. What is the difference between the Expenses (% of total expenses) of Caribbean small states in 2005 and the Expenses (% of total expenses) of Maldives in 2009?
Give a very brief answer. -9.98. What is the difference between the Expenses (% of total expenses) in Caribbean small states in 2005 and the Expenses (% of total expenses) in Trinidad and Tobago in 2009?
Your answer should be compact. -1.95. What is the difference between the Expenses (% of total expenses) of Cambodia in 2005 and the Expenses (% of total expenses) of Maldives in 2009?
Offer a very short reply. 2.77. What is the difference between the Expenses (% of total expenses) of Cambodia in 2005 and the Expenses (% of total expenses) of Trinidad and Tobago in 2009?
Your answer should be compact. 10.8. What is the difference between the Expenses (% of total expenses) of Maldives in 2005 and the Expenses (% of total expenses) of Trinidad and Tobago in 2009?
Offer a terse response. -4.58. What is the difference between the Expenses (% of total expenses) of Caribbean small states in 2006 and the Expenses (% of total expenses) of Cambodia in 2007?
Your answer should be compact. -17.63. What is the difference between the Expenses (% of total expenses) in Caribbean small states in 2006 and the Expenses (% of total expenses) in Maldives in 2007?
Your answer should be compact. 0.77. What is the difference between the Expenses (% of total expenses) of Caribbean small states in 2006 and the Expenses (% of total expenses) of Trinidad and Tobago in 2007?
Keep it short and to the point. -7.06. What is the difference between the Expenses (% of total expenses) of Cambodia in 2006 and the Expenses (% of total expenses) of Maldives in 2007?
Ensure brevity in your answer.  14.61. What is the difference between the Expenses (% of total expenses) in Cambodia in 2006 and the Expenses (% of total expenses) in Trinidad and Tobago in 2007?
Your answer should be compact. 6.77. What is the difference between the Expenses (% of total expenses) of Maldives in 2006 and the Expenses (% of total expenses) of Trinidad and Tobago in 2007?
Make the answer very short. -6.91. What is the difference between the Expenses (% of total expenses) of Caribbean small states in 2006 and the Expenses (% of total expenses) of Cambodia in 2008?
Offer a very short reply. -19.69. What is the difference between the Expenses (% of total expenses) in Caribbean small states in 2006 and the Expenses (% of total expenses) in Maldives in 2008?
Give a very brief answer. -15.49. What is the difference between the Expenses (% of total expenses) of Caribbean small states in 2006 and the Expenses (% of total expenses) of Trinidad and Tobago in 2008?
Ensure brevity in your answer.  -2.3. What is the difference between the Expenses (% of total expenses) in Cambodia in 2006 and the Expenses (% of total expenses) in Maldives in 2008?
Provide a succinct answer. -1.66. What is the difference between the Expenses (% of total expenses) of Cambodia in 2006 and the Expenses (% of total expenses) of Trinidad and Tobago in 2008?
Offer a very short reply. 11.54. What is the difference between the Expenses (% of total expenses) in Maldives in 2006 and the Expenses (% of total expenses) in Trinidad and Tobago in 2008?
Ensure brevity in your answer.  -2.14. What is the difference between the Expenses (% of total expenses) in Caribbean small states in 2006 and the Expenses (% of total expenses) in Cambodia in 2009?
Provide a succinct answer. -18.68. What is the difference between the Expenses (% of total expenses) of Caribbean small states in 2006 and the Expenses (% of total expenses) of Maldives in 2009?
Your answer should be compact. -14.4. What is the difference between the Expenses (% of total expenses) of Caribbean small states in 2006 and the Expenses (% of total expenses) of Trinidad and Tobago in 2009?
Keep it short and to the point. -6.37. What is the difference between the Expenses (% of total expenses) of Cambodia in 2006 and the Expenses (% of total expenses) of Maldives in 2009?
Offer a very short reply. -0.57. What is the difference between the Expenses (% of total expenses) in Cambodia in 2006 and the Expenses (% of total expenses) in Trinidad and Tobago in 2009?
Your response must be concise. 7.46. What is the difference between the Expenses (% of total expenses) in Maldives in 2006 and the Expenses (% of total expenses) in Trinidad and Tobago in 2009?
Make the answer very short. -6.22. What is the difference between the Expenses (% of total expenses) in Caribbean small states in 2007 and the Expenses (% of total expenses) in Cambodia in 2008?
Provide a succinct answer. -17.91. What is the difference between the Expenses (% of total expenses) of Caribbean small states in 2007 and the Expenses (% of total expenses) of Maldives in 2008?
Your response must be concise. -13.71. What is the difference between the Expenses (% of total expenses) of Caribbean small states in 2007 and the Expenses (% of total expenses) of Trinidad and Tobago in 2008?
Give a very brief answer. -0.51. What is the difference between the Expenses (% of total expenses) of Cambodia in 2007 and the Expenses (% of total expenses) of Maldives in 2008?
Provide a succinct answer. 2.13. What is the difference between the Expenses (% of total expenses) of Cambodia in 2007 and the Expenses (% of total expenses) of Trinidad and Tobago in 2008?
Your answer should be very brief. 15.33. What is the difference between the Expenses (% of total expenses) in Maldives in 2007 and the Expenses (% of total expenses) in Trinidad and Tobago in 2008?
Offer a terse response. -3.07. What is the difference between the Expenses (% of total expenses) in Caribbean small states in 2007 and the Expenses (% of total expenses) in Cambodia in 2009?
Your response must be concise. -16.9. What is the difference between the Expenses (% of total expenses) of Caribbean small states in 2007 and the Expenses (% of total expenses) of Maldives in 2009?
Provide a short and direct response. -12.62. What is the difference between the Expenses (% of total expenses) of Caribbean small states in 2007 and the Expenses (% of total expenses) of Trinidad and Tobago in 2009?
Keep it short and to the point. -4.59. What is the difference between the Expenses (% of total expenses) of Cambodia in 2007 and the Expenses (% of total expenses) of Maldives in 2009?
Offer a very short reply. 3.22. What is the difference between the Expenses (% of total expenses) of Cambodia in 2007 and the Expenses (% of total expenses) of Trinidad and Tobago in 2009?
Your answer should be compact. 11.25. What is the difference between the Expenses (% of total expenses) in Maldives in 2007 and the Expenses (% of total expenses) in Trinidad and Tobago in 2009?
Your answer should be very brief. -7.15. What is the difference between the Expenses (% of total expenses) of Caribbean small states in 2008 and the Expenses (% of total expenses) of Cambodia in 2009?
Keep it short and to the point. -18.85. What is the difference between the Expenses (% of total expenses) in Caribbean small states in 2008 and the Expenses (% of total expenses) in Maldives in 2009?
Your answer should be compact. -14.57. What is the difference between the Expenses (% of total expenses) in Caribbean small states in 2008 and the Expenses (% of total expenses) in Trinidad and Tobago in 2009?
Give a very brief answer. -6.54. What is the difference between the Expenses (% of total expenses) in Cambodia in 2008 and the Expenses (% of total expenses) in Maldives in 2009?
Your response must be concise. 5.29. What is the difference between the Expenses (% of total expenses) of Cambodia in 2008 and the Expenses (% of total expenses) of Trinidad and Tobago in 2009?
Keep it short and to the point. 13.32. What is the difference between the Expenses (% of total expenses) in Maldives in 2008 and the Expenses (% of total expenses) in Trinidad and Tobago in 2009?
Provide a short and direct response. 9.12. What is the average Expenses (% of total expenses) in Caribbean small states per year?
Offer a terse response. 24.94. What is the average Expenses (% of total expenses) in Cambodia per year?
Ensure brevity in your answer.  36.55. What is the average Expenses (% of total expenses) in Maldives per year?
Offer a terse response. 25.27. What is the average Expenses (% of total expenses) of Trinidad and Tobago per year?
Provide a succinct answer. 29.28. In the year 2002, what is the difference between the Expenses (% of total expenses) in Caribbean small states and Expenses (% of total expenses) in Cambodia?
Your response must be concise. 0.53. In the year 2002, what is the difference between the Expenses (% of total expenses) in Caribbean small states and Expenses (% of total expenses) in Maldives?
Ensure brevity in your answer.  12.49. In the year 2002, what is the difference between the Expenses (% of total expenses) of Caribbean small states and Expenses (% of total expenses) of Trinidad and Tobago?
Offer a terse response. 0. In the year 2002, what is the difference between the Expenses (% of total expenses) of Cambodia and Expenses (% of total expenses) of Maldives?
Your answer should be very brief. 11.96. In the year 2002, what is the difference between the Expenses (% of total expenses) of Cambodia and Expenses (% of total expenses) of Trinidad and Tobago?
Provide a short and direct response. -0.53. In the year 2002, what is the difference between the Expenses (% of total expenses) of Maldives and Expenses (% of total expenses) of Trinidad and Tobago?
Ensure brevity in your answer.  -12.49. In the year 2003, what is the difference between the Expenses (% of total expenses) of Caribbean small states and Expenses (% of total expenses) of Cambodia?
Give a very brief answer. -0.56. In the year 2003, what is the difference between the Expenses (% of total expenses) of Caribbean small states and Expenses (% of total expenses) of Maldives?
Your answer should be very brief. 11.09. In the year 2003, what is the difference between the Expenses (% of total expenses) in Caribbean small states and Expenses (% of total expenses) in Trinidad and Tobago?
Provide a succinct answer. -1.82. In the year 2003, what is the difference between the Expenses (% of total expenses) of Cambodia and Expenses (% of total expenses) of Maldives?
Ensure brevity in your answer.  11.65. In the year 2003, what is the difference between the Expenses (% of total expenses) in Cambodia and Expenses (% of total expenses) in Trinidad and Tobago?
Make the answer very short. -1.26. In the year 2003, what is the difference between the Expenses (% of total expenses) of Maldives and Expenses (% of total expenses) of Trinidad and Tobago?
Ensure brevity in your answer.  -12.91. In the year 2004, what is the difference between the Expenses (% of total expenses) of Caribbean small states and Expenses (% of total expenses) of Cambodia?
Give a very brief answer. -12.87. In the year 2004, what is the difference between the Expenses (% of total expenses) in Caribbean small states and Expenses (% of total expenses) in Maldives?
Keep it short and to the point. -2.17. In the year 2004, what is the difference between the Expenses (% of total expenses) in Caribbean small states and Expenses (% of total expenses) in Trinidad and Tobago?
Your answer should be compact. -9.36. In the year 2004, what is the difference between the Expenses (% of total expenses) in Cambodia and Expenses (% of total expenses) in Maldives?
Provide a short and direct response. 10.7. In the year 2004, what is the difference between the Expenses (% of total expenses) in Cambodia and Expenses (% of total expenses) in Trinidad and Tobago?
Your answer should be very brief. 3.51. In the year 2004, what is the difference between the Expenses (% of total expenses) in Maldives and Expenses (% of total expenses) in Trinidad and Tobago?
Provide a succinct answer. -7.19. In the year 2005, what is the difference between the Expenses (% of total expenses) of Caribbean small states and Expenses (% of total expenses) of Cambodia?
Your answer should be very brief. -12.75. In the year 2005, what is the difference between the Expenses (% of total expenses) in Caribbean small states and Expenses (% of total expenses) in Maldives?
Offer a very short reply. 2.64. In the year 2005, what is the difference between the Expenses (% of total expenses) in Caribbean small states and Expenses (% of total expenses) in Trinidad and Tobago?
Give a very brief answer. -7.86. In the year 2005, what is the difference between the Expenses (% of total expenses) in Cambodia and Expenses (% of total expenses) in Maldives?
Your response must be concise. 15.39. In the year 2005, what is the difference between the Expenses (% of total expenses) of Cambodia and Expenses (% of total expenses) of Trinidad and Tobago?
Offer a very short reply. 4.89. In the year 2005, what is the difference between the Expenses (% of total expenses) of Maldives and Expenses (% of total expenses) of Trinidad and Tobago?
Make the answer very short. -10.5. In the year 2006, what is the difference between the Expenses (% of total expenses) in Caribbean small states and Expenses (% of total expenses) in Cambodia?
Ensure brevity in your answer.  -13.84. In the year 2006, what is the difference between the Expenses (% of total expenses) of Caribbean small states and Expenses (% of total expenses) of Maldives?
Make the answer very short. -0.16. In the year 2006, what is the difference between the Expenses (% of total expenses) in Caribbean small states and Expenses (% of total expenses) in Trinidad and Tobago?
Provide a short and direct response. -2.54. In the year 2006, what is the difference between the Expenses (% of total expenses) in Cambodia and Expenses (% of total expenses) in Maldives?
Provide a short and direct response. 13.68. In the year 2006, what is the difference between the Expenses (% of total expenses) of Cambodia and Expenses (% of total expenses) of Trinidad and Tobago?
Provide a succinct answer. 11.3. In the year 2006, what is the difference between the Expenses (% of total expenses) in Maldives and Expenses (% of total expenses) in Trinidad and Tobago?
Your answer should be compact. -2.38. In the year 2007, what is the difference between the Expenses (% of total expenses) in Caribbean small states and Expenses (% of total expenses) in Cambodia?
Your answer should be very brief. -15.85. In the year 2007, what is the difference between the Expenses (% of total expenses) of Caribbean small states and Expenses (% of total expenses) of Maldives?
Your answer should be compact. 2.55. In the year 2007, what is the difference between the Expenses (% of total expenses) in Caribbean small states and Expenses (% of total expenses) in Trinidad and Tobago?
Make the answer very short. -5.28. In the year 2007, what is the difference between the Expenses (% of total expenses) of Cambodia and Expenses (% of total expenses) of Maldives?
Offer a very short reply. 18.4. In the year 2007, what is the difference between the Expenses (% of total expenses) of Cambodia and Expenses (% of total expenses) of Trinidad and Tobago?
Offer a very short reply. 10.57. In the year 2007, what is the difference between the Expenses (% of total expenses) in Maldives and Expenses (% of total expenses) in Trinidad and Tobago?
Your response must be concise. -7.83. In the year 2008, what is the difference between the Expenses (% of total expenses) in Caribbean small states and Expenses (% of total expenses) in Cambodia?
Keep it short and to the point. -19.86. In the year 2008, what is the difference between the Expenses (% of total expenses) of Caribbean small states and Expenses (% of total expenses) of Maldives?
Your answer should be compact. -15.66. In the year 2008, what is the difference between the Expenses (% of total expenses) in Caribbean small states and Expenses (% of total expenses) in Trinidad and Tobago?
Keep it short and to the point. -2.46. In the year 2008, what is the difference between the Expenses (% of total expenses) in Cambodia and Expenses (% of total expenses) in Maldives?
Your answer should be compact. 4.19. In the year 2008, what is the difference between the Expenses (% of total expenses) in Cambodia and Expenses (% of total expenses) in Trinidad and Tobago?
Your answer should be very brief. 17.39. In the year 2008, what is the difference between the Expenses (% of total expenses) in Maldives and Expenses (% of total expenses) in Trinidad and Tobago?
Provide a succinct answer. 13.2. In the year 2009, what is the difference between the Expenses (% of total expenses) of Caribbean small states and Expenses (% of total expenses) of Cambodia?
Offer a terse response. -17.69. In the year 2009, what is the difference between the Expenses (% of total expenses) of Caribbean small states and Expenses (% of total expenses) of Maldives?
Your answer should be compact. -13.41. In the year 2009, what is the difference between the Expenses (% of total expenses) of Caribbean small states and Expenses (% of total expenses) of Trinidad and Tobago?
Provide a short and direct response. -5.38. In the year 2009, what is the difference between the Expenses (% of total expenses) in Cambodia and Expenses (% of total expenses) in Maldives?
Provide a succinct answer. 4.28. In the year 2009, what is the difference between the Expenses (% of total expenses) in Cambodia and Expenses (% of total expenses) in Trinidad and Tobago?
Provide a succinct answer. 12.31. In the year 2009, what is the difference between the Expenses (% of total expenses) of Maldives and Expenses (% of total expenses) of Trinidad and Tobago?
Offer a terse response. 8.03. What is the ratio of the Expenses (% of total expenses) in Caribbean small states in 2002 to that in 2003?
Your response must be concise. 1.08. What is the ratio of the Expenses (% of total expenses) in Cambodia in 2002 to that in 2003?
Provide a short and direct response. 1.04. What is the ratio of the Expenses (% of total expenses) in Maldives in 2002 to that in 2003?
Provide a short and direct response. 1.05. What is the ratio of the Expenses (% of total expenses) of Trinidad and Tobago in 2002 to that in 2003?
Offer a very short reply. 1.02. What is the ratio of the Expenses (% of total expenses) of Caribbean small states in 2002 to that in 2004?
Make the answer very short. 1.6. What is the ratio of the Expenses (% of total expenses) in Cambodia in 2002 to that in 2004?
Provide a succinct answer. 1.02. What is the ratio of the Expenses (% of total expenses) of Maldives in 2002 to that in 2004?
Offer a terse response. 0.98. What is the ratio of the Expenses (% of total expenses) of Trinidad and Tobago in 2002 to that in 2004?
Offer a terse response. 1.15. What is the ratio of the Expenses (% of total expenses) in Caribbean small states in 2002 to that in 2005?
Make the answer very short. 1.6. What is the ratio of the Expenses (% of total expenses) of Cambodia in 2002 to that in 2005?
Provide a succinct answer. 1.02. What is the ratio of the Expenses (% of total expenses) of Maldives in 2002 to that in 2005?
Your answer should be very brief. 1.21. What is the ratio of the Expenses (% of total expenses) in Trinidad and Tobago in 2002 to that in 2005?
Offer a terse response. 1.2. What is the ratio of the Expenses (% of total expenses) in Caribbean small states in 2002 to that in 2006?
Make the answer very short. 1.97. What is the ratio of the Expenses (% of total expenses) in Cambodia in 2002 to that in 2006?
Offer a terse response. 1.13. What is the ratio of the Expenses (% of total expenses) in Maldives in 2002 to that in 2006?
Give a very brief answer. 1.31. What is the ratio of the Expenses (% of total expenses) of Trinidad and Tobago in 2002 to that in 2006?
Offer a very short reply. 1.74. What is the ratio of the Expenses (% of total expenses) of Caribbean small states in 2002 to that in 2007?
Offer a very short reply. 1.8. What is the ratio of the Expenses (% of total expenses) in Cambodia in 2002 to that in 2007?
Your response must be concise. 1.01. What is the ratio of the Expenses (% of total expenses) of Maldives in 2002 to that in 2007?
Provide a short and direct response. 1.37. What is the ratio of the Expenses (% of total expenses) in Trinidad and Tobago in 2002 to that in 2007?
Your response must be concise. 1.44. What is the ratio of the Expenses (% of total expenses) in Caribbean small states in 2002 to that in 2008?
Your answer should be very brief. 1.99. What is the ratio of the Expenses (% of total expenses) in Cambodia in 2002 to that in 2008?
Ensure brevity in your answer.  0.96. What is the ratio of the Expenses (% of total expenses) in Maldives in 2002 to that in 2008?
Make the answer very short. 0.73. What is the ratio of the Expenses (% of total expenses) in Trinidad and Tobago in 2002 to that in 2008?
Make the answer very short. 1.76. What is the ratio of the Expenses (% of total expenses) of Caribbean small states in 2002 to that in 2009?
Ensure brevity in your answer.  1.87. What is the ratio of the Expenses (% of total expenses) of Maldives in 2002 to that in 2009?
Your answer should be very brief. 0.75. What is the ratio of the Expenses (% of total expenses) of Trinidad and Tobago in 2002 to that in 2009?
Your answer should be compact. 1.48. What is the ratio of the Expenses (% of total expenses) in Caribbean small states in 2003 to that in 2004?
Offer a terse response. 1.49. What is the ratio of the Expenses (% of total expenses) in Cambodia in 2003 to that in 2004?
Provide a short and direct response. 0.98. What is the ratio of the Expenses (% of total expenses) in Maldives in 2003 to that in 2004?
Make the answer very short. 0.93. What is the ratio of the Expenses (% of total expenses) in Trinidad and Tobago in 2003 to that in 2004?
Keep it short and to the point. 1.12. What is the ratio of the Expenses (% of total expenses) in Caribbean small states in 2003 to that in 2005?
Offer a terse response. 1.49. What is the ratio of the Expenses (% of total expenses) in Cambodia in 2003 to that in 2005?
Give a very brief answer. 0.98. What is the ratio of the Expenses (% of total expenses) of Maldives in 2003 to that in 2005?
Ensure brevity in your answer.  1.15. What is the ratio of the Expenses (% of total expenses) in Trinidad and Tobago in 2003 to that in 2005?
Provide a succinct answer. 1.17. What is the ratio of the Expenses (% of total expenses) of Caribbean small states in 2003 to that in 2006?
Offer a very short reply. 1.83. What is the ratio of the Expenses (% of total expenses) in Cambodia in 2003 to that in 2006?
Your response must be concise. 1.08. What is the ratio of the Expenses (% of total expenses) in Maldives in 2003 to that in 2006?
Provide a succinct answer. 1.24. What is the ratio of the Expenses (% of total expenses) in Trinidad and Tobago in 2003 to that in 2006?
Provide a short and direct response. 1.7. What is the ratio of the Expenses (% of total expenses) in Caribbean small states in 2003 to that in 2007?
Your answer should be very brief. 1.68. What is the ratio of the Expenses (% of total expenses) in Cambodia in 2003 to that in 2007?
Ensure brevity in your answer.  0.97. What is the ratio of the Expenses (% of total expenses) in Maldives in 2003 to that in 2007?
Offer a very short reply. 1.31. What is the ratio of the Expenses (% of total expenses) of Trinidad and Tobago in 2003 to that in 2007?
Offer a very short reply. 1.41. What is the ratio of the Expenses (% of total expenses) in Caribbean small states in 2003 to that in 2008?
Offer a very short reply. 1.85. What is the ratio of the Expenses (% of total expenses) in Cambodia in 2003 to that in 2008?
Make the answer very short. 0.92. What is the ratio of the Expenses (% of total expenses) in Maldives in 2003 to that in 2008?
Provide a succinct answer. 0.69. What is the ratio of the Expenses (% of total expenses) in Trinidad and Tobago in 2003 to that in 2008?
Provide a short and direct response. 1.72. What is the ratio of the Expenses (% of total expenses) in Caribbean small states in 2003 to that in 2009?
Your response must be concise. 1.74. What is the ratio of the Expenses (% of total expenses) of Cambodia in 2003 to that in 2009?
Your response must be concise. 0.94. What is the ratio of the Expenses (% of total expenses) of Maldives in 2003 to that in 2009?
Your response must be concise. 0.72. What is the ratio of the Expenses (% of total expenses) in Trinidad and Tobago in 2003 to that in 2009?
Provide a succinct answer. 1.45. What is the ratio of the Expenses (% of total expenses) in Caribbean small states in 2004 to that in 2005?
Offer a terse response. 1. What is the ratio of the Expenses (% of total expenses) in Maldives in 2004 to that in 2005?
Provide a succinct answer. 1.23. What is the ratio of the Expenses (% of total expenses) in Trinidad and Tobago in 2004 to that in 2005?
Provide a short and direct response. 1.05. What is the ratio of the Expenses (% of total expenses) of Caribbean small states in 2004 to that in 2006?
Offer a very short reply. 1.23. What is the ratio of the Expenses (% of total expenses) in Cambodia in 2004 to that in 2006?
Offer a terse response. 1.1. What is the ratio of the Expenses (% of total expenses) of Maldives in 2004 to that in 2006?
Give a very brief answer. 1.33. What is the ratio of the Expenses (% of total expenses) in Trinidad and Tobago in 2004 to that in 2006?
Keep it short and to the point. 1.52. What is the ratio of the Expenses (% of total expenses) in Caribbean small states in 2004 to that in 2007?
Offer a very short reply. 1.13. What is the ratio of the Expenses (% of total expenses) in Cambodia in 2004 to that in 2007?
Your response must be concise. 0.99. What is the ratio of the Expenses (% of total expenses) of Maldives in 2004 to that in 2007?
Offer a terse response. 1.4. What is the ratio of the Expenses (% of total expenses) of Trinidad and Tobago in 2004 to that in 2007?
Your response must be concise. 1.26. What is the ratio of the Expenses (% of total expenses) in Caribbean small states in 2004 to that in 2008?
Provide a short and direct response. 1.24. What is the ratio of the Expenses (% of total expenses) in Cambodia in 2004 to that in 2008?
Ensure brevity in your answer.  0.94. What is the ratio of the Expenses (% of total expenses) in Maldives in 2004 to that in 2008?
Make the answer very short. 0.74. What is the ratio of the Expenses (% of total expenses) in Trinidad and Tobago in 2004 to that in 2008?
Provide a succinct answer. 1.53. What is the ratio of the Expenses (% of total expenses) of Caribbean small states in 2004 to that in 2009?
Your answer should be very brief. 1.17. What is the ratio of the Expenses (% of total expenses) of Cambodia in 2004 to that in 2009?
Keep it short and to the point. 0.96. What is the ratio of the Expenses (% of total expenses) in Maldives in 2004 to that in 2009?
Your answer should be compact. 0.77. What is the ratio of the Expenses (% of total expenses) in Trinidad and Tobago in 2004 to that in 2009?
Keep it short and to the point. 1.29. What is the ratio of the Expenses (% of total expenses) in Caribbean small states in 2005 to that in 2006?
Give a very brief answer. 1.23. What is the ratio of the Expenses (% of total expenses) in Cambodia in 2005 to that in 2006?
Provide a short and direct response. 1.1. What is the ratio of the Expenses (% of total expenses) of Maldives in 2005 to that in 2006?
Your response must be concise. 1.08. What is the ratio of the Expenses (% of total expenses) in Trinidad and Tobago in 2005 to that in 2006?
Offer a very short reply. 1.45. What is the ratio of the Expenses (% of total expenses) of Caribbean small states in 2005 to that in 2007?
Your response must be concise. 1.13. What is the ratio of the Expenses (% of total expenses) in Maldives in 2005 to that in 2007?
Your answer should be compact. 1.14. What is the ratio of the Expenses (% of total expenses) in Trinidad and Tobago in 2005 to that in 2007?
Provide a succinct answer. 1.2. What is the ratio of the Expenses (% of total expenses) in Caribbean small states in 2005 to that in 2008?
Give a very brief answer. 1.24. What is the ratio of the Expenses (% of total expenses) of Cambodia in 2005 to that in 2008?
Make the answer very short. 0.94. What is the ratio of the Expenses (% of total expenses) in Maldives in 2005 to that in 2008?
Offer a very short reply. 0.6. What is the ratio of the Expenses (% of total expenses) in Trinidad and Tobago in 2005 to that in 2008?
Keep it short and to the point. 1.46. What is the ratio of the Expenses (% of total expenses) in Caribbean small states in 2005 to that in 2009?
Your answer should be compact. 1.17. What is the ratio of the Expenses (% of total expenses) of Cambodia in 2005 to that in 2009?
Your answer should be compact. 0.96. What is the ratio of the Expenses (% of total expenses) in Maldives in 2005 to that in 2009?
Ensure brevity in your answer.  0.62. What is the ratio of the Expenses (% of total expenses) of Trinidad and Tobago in 2005 to that in 2009?
Your response must be concise. 1.23. What is the ratio of the Expenses (% of total expenses) of Caribbean small states in 2006 to that in 2007?
Give a very brief answer. 0.92. What is the ratio of the Expenses (% of total expenses) of Cambodia in 2006 to that in 2007?
Give a very brief answer. 0.9. What is the ratio of the Expenses (% of total expenses) of Maldives in 2006 to that in 2007?
Offer a very short reply. 1.05. What is the ratio of the Expenses (% of total expenses) of Trinidad and Tobago in 2006 to that in 2007?
Keep it short and to the point. 0.83. What is the ratio of the Expenses (% of total expenses) in Caribbean small states in 2006 to that in 2008?
Your answer should be very brief. 1.01. What is the ratio of the Expenses (% of total expenses) of Cambodia in 2006 to that in 2008?
Provide a succinct answer. 0.85. What is the ratio of the Expenses (% of total expenses) of Maldives in 2006 to that in 2008?
Your answer should be compact. 0.56. What is the ratio of the Expenses (% of total expenses) of Trinidad and Tobago in 2006 to that in 2008?
Provide a succinct answer. 1.01. What is the ratio of the Expenses (% of total expenses) of Caribbean small states in 2006 to that in 2009?
Your response must be concise. 0.95. What is the ratio of the Expenses (% of total expenses) of Cambodia in 2006 to that in 2009?
Provide a succinct answer. 0.87. What is the ratio of the Expenses (% of total expenses) of Maldives in 2006 to that in 2009?
Your answer should be compact. 0.58. What is the ratio of the Expenses (% of total expenses) in Trinidad and Tobago in 2006 to that in 2009?
Keep it short and to the point. 0.85. What is the ratio of the Expenses (% of total expenses) in Caribbean small states in 2007 to that in 2008?
Keep it short and to the point. 1.1. What is the ratio of the Expenses (% of total expenses) of Cambodia in 2007 to that in 2008?
Make the answer very short. 0.95. What is the ratio of the Expenses (% of total expenses) of Maldives in 2007 to that in 2008?
Your answer should be very brief. 0.53. What is the ratio of the Expenses (% of total expenses) in Trinidad and Tobago in 2007 to that in 2008?
Provide a short and direct response. 1.22. What is the ratio of the Expenses (% of total expenses) in Caribbean small states in 2007 to that in 2009?
Give a very brief answer. 1.04. What is the ratio of the Expenses (% of total expenses) in Cambodia in 2007 to that in 2009?
Provide a short and direct response. 0.97. What is the ratio of the Expenses (% of total expenses) of Maldives in 2007 to that in 2009?
Offer a very short reply. 0.55. What is the ratio of the Expenses (% of total expenses) of Trinidad and Tobago in 2007 to that in 2009?
Give a very brief answer. 1.03. What is the ratio of the Expenses (% of total expenses) of Caribbean small states in 2008 to that in 2009?
Provide a short and direct response. 0.94. What is the ratio of the Expenses (% of total expenses) of Cambodia in 2008 to that in 2009?
Give a very brief answer. 1.03. What is the ratio of the Expenses (% of total expenses) of Maldives in 2008 to that in 2009?
Your answer should be very brief. 1.03. What is the ratio of the Expenses (% of total expenses) in Trinidad and Tobago in 2008 to that in 2009?
Your answer should be compact. 0.84. What is the difference between the highest and the second highest Expenses (% of total expenses) of Caribbean small states?
Give a very brief answer. 2.66. What is the difference between the highest and the second highest Expenses (% of total expenses) of Cambodia?
Make the answer very short. 1.01. What is the difference between the highest and the second highest Expenses (% of total expenses) of Maldives?
Offer a terse response. 1.09. What is the difference between the highest and the second highest Expenses (% of total expenses) of Trinidad and Tobago?
Offer a terse response. 0.84. What is the difference between the highest and the lowest Expenses (% of total expenses) of Caribbean small states?
Your response must be concise. 18.77. What is the difference between the highest and the lowest Expenses (% of total expenses) in Cambodia?
Make the answer very short. 5.85. What is the difference between the highest and the lowest Expenses (% of total expenses) in Maldives?
Offer a terse response. 16.27. What is the difference between the highest and the lowest Expenses (% of total expenses) in Trinidad and Tobago?
Provide a short and direct response. 16.31. 